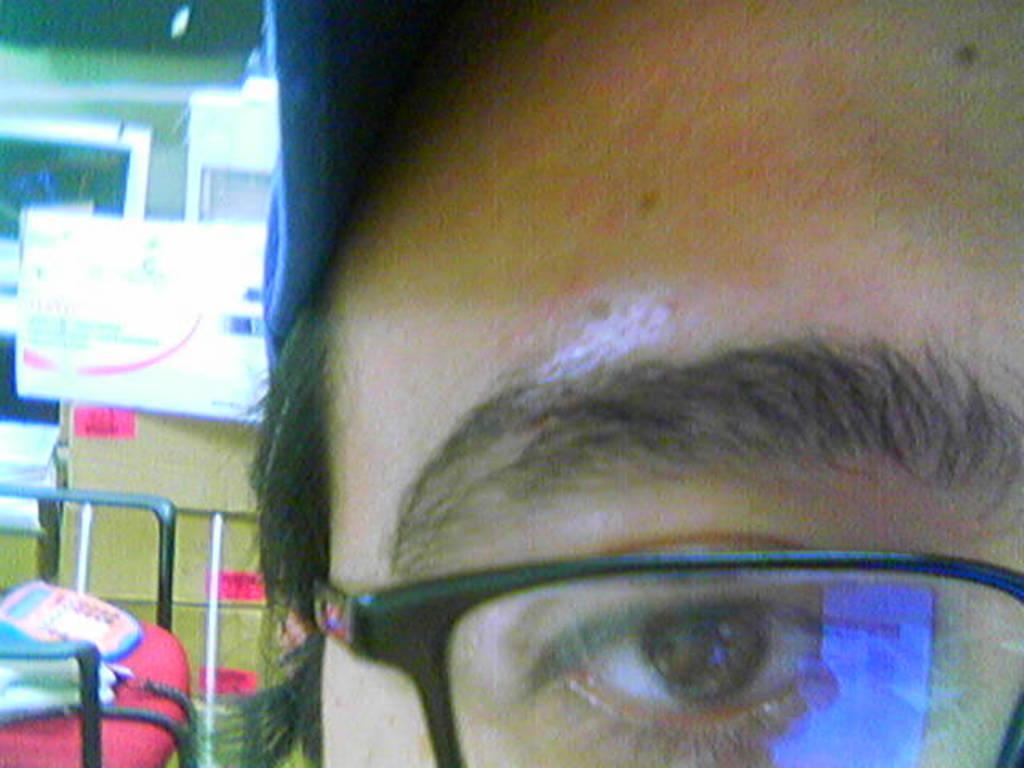Please provide a concise description of this image. In this picture we can see a person, a person wore spectacles and a cap, in the background there are some cardboard boxes, we can see a board here, there is a chair at the left bottom. 